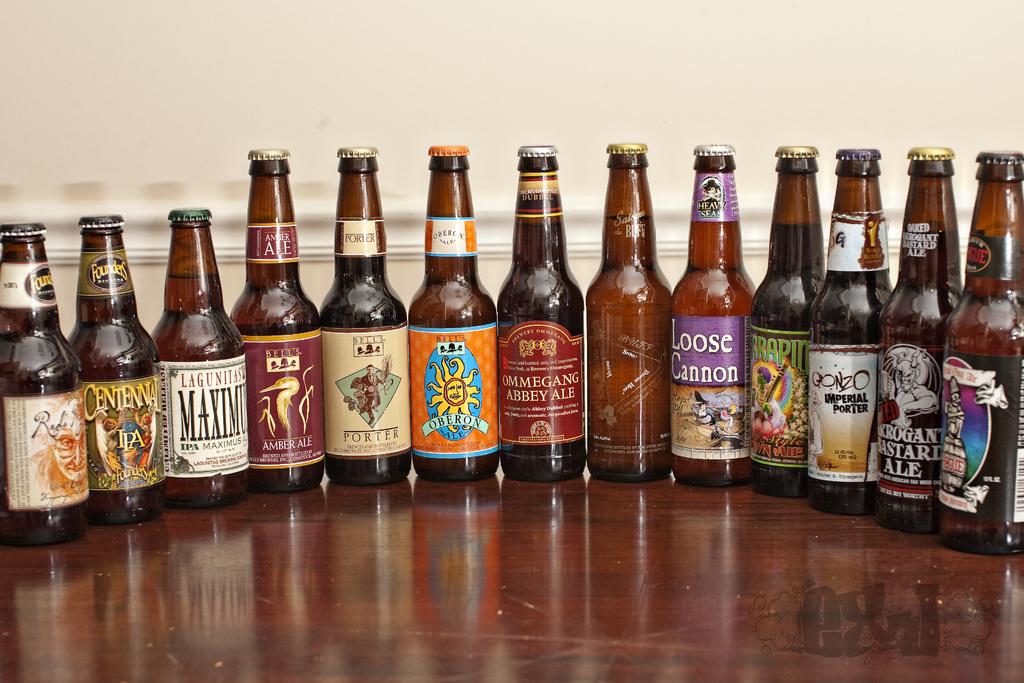What type of beer is in the gonzo bottle?
Keep it short and to the point. Imperial porter. 